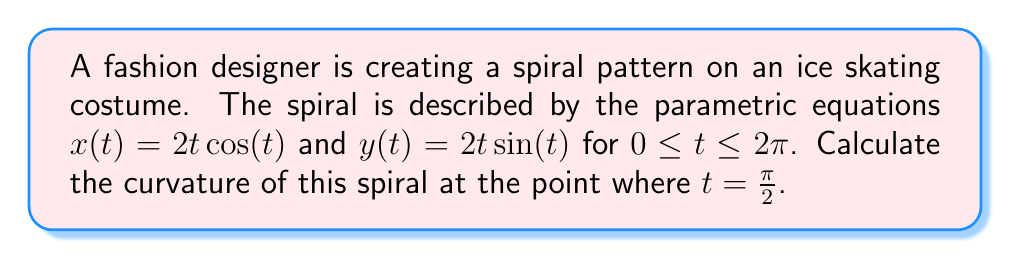Show me your answer to this math problem. To calculate the curvature of the spiral, we'll follow these steps:

1) The curvature formula for a parametric curve is:

   $$\kappa = \frac{|\dot{x}\ddot{y} - \dot{y}\ddot{x}|}{(\dot{x}^2 + \dot{y}^2)^{3/2}}$$

2) First, let's calculate the first and second derivatives:
   
   $\dot{x} = 2\cos(t) - 2t\sin(t)$
   $\dot{y} = 2\sin(t) + 2t\cos(t)$
   
   $\ddot{x} = -4\sin(t) - 2t\cos(t)$
   $\ddot{y} = 4\cos(t) - 2t\sin(t)$

3) Now, let's evaluate these at $t = \frac{\pi}{2}$:
   
   $\dot{x}(\frac{\pi}{2}) = -\pi$
   $\dot{y}(\frac{\pi}{2}) = 2$
   
   $\ddot{x}(\frac{\pi}{2}) = -2$
   $\ddot{y}(\frac{\pi}{2}) = -\pi$

4) Substitute these values into the curvature formula:

   $$\kappa = \frac{|(-\pi)(-\pi) - (2)(-2)|}{((-\pi)^2 + 2^2)^{3/2}}$$

5) Simplify:

   $$\kappa = \frac{|\pi^2 - 4|}{(\pi^2 + 4)^{3/2}}$$

6) Calculate the final value:

   $$\kappa \approx 0.2738$$
Answer: $\frac{|\pi^2 - 4|}{(\pi^2 + 4)^{3/2}} \approx 0.2738$ 